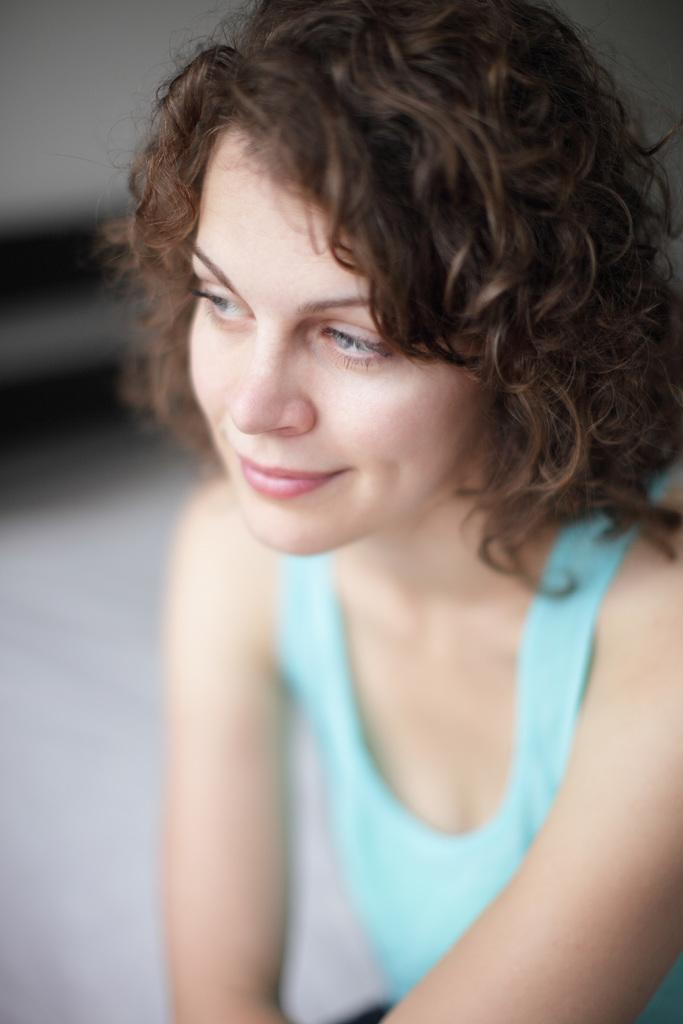Who is present in the image? There is a woman in the image. What expression does the woman have? The woman is smiling. Can you describe the background of the image? The background of the image is blurry. What type of scarf is the woman wearing in the image? There is no scarf visible in the image. How many ants can be seen crawling on the woman's face in the image? There are no ants present in the image. 